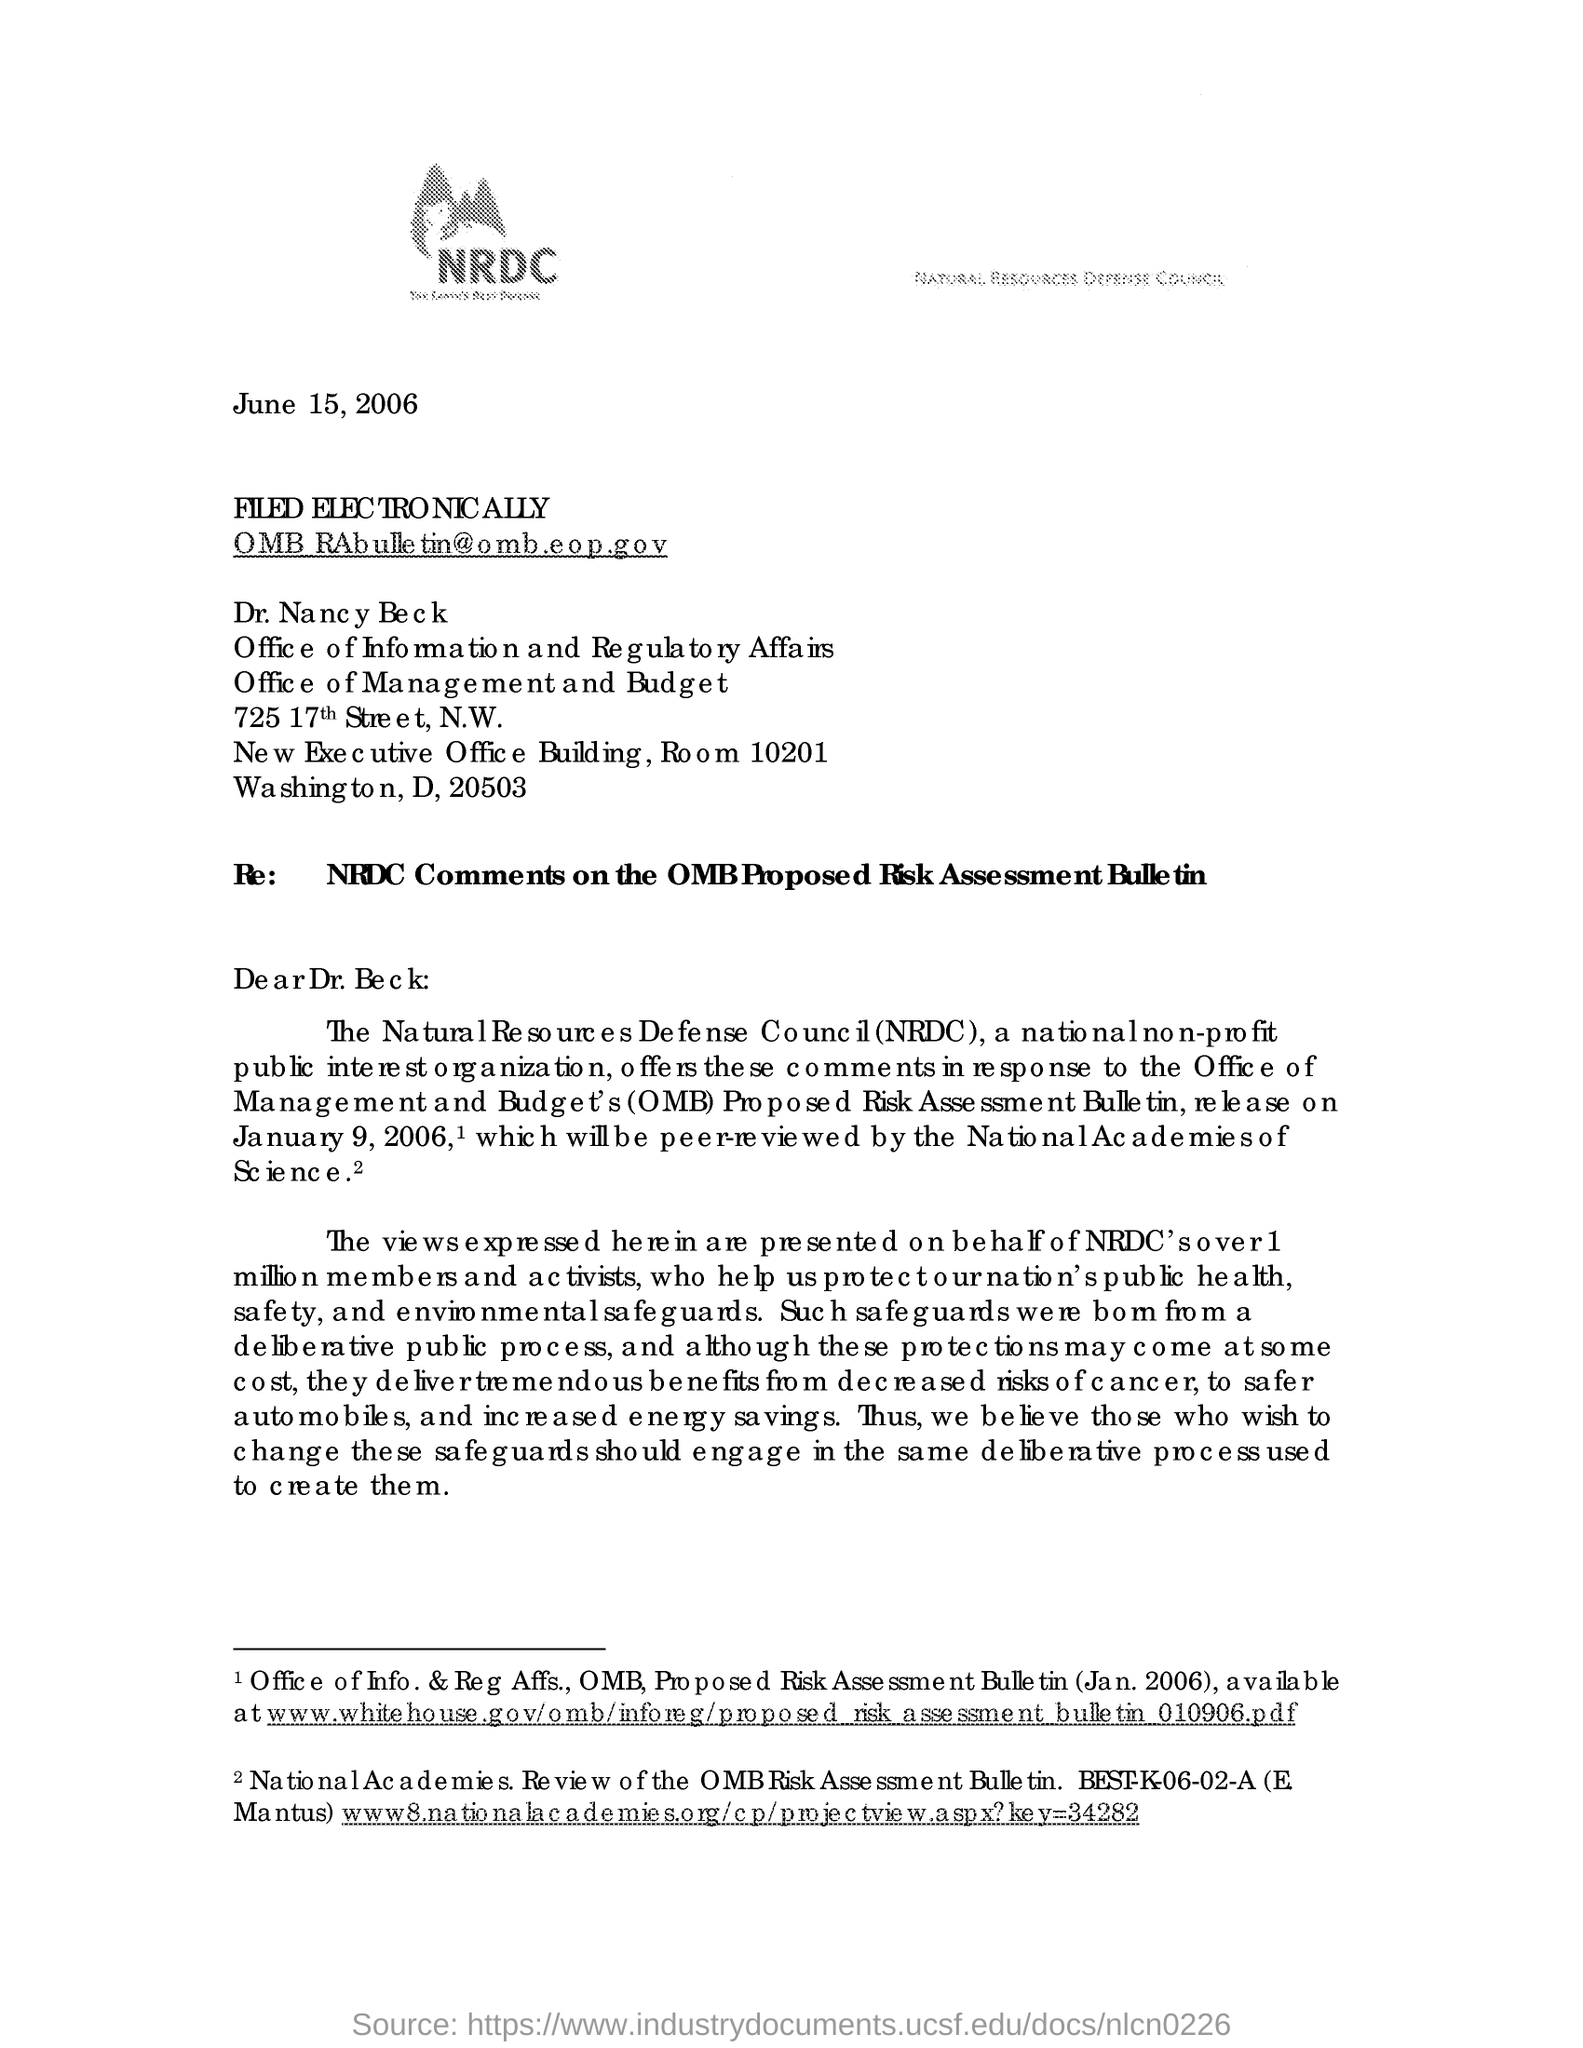What is the issued date of this document?
Offer a terse response. June 15, 2006. Who is the addressee of this letter?
Keep it short and to the point. Dr. Nancy Beck. What is the fullform of NRDC?
Provide a succinct answer. Natural Resources Defense Council. What kind of organization is NRDC?
Ensure brevity in your answer.  A national non-profit public interest organization. What is the subject line of this letter?
Provide a short and direct response. Re:    NRDC Comments on the OMB Proposed Risk Assessment Bulletin. 